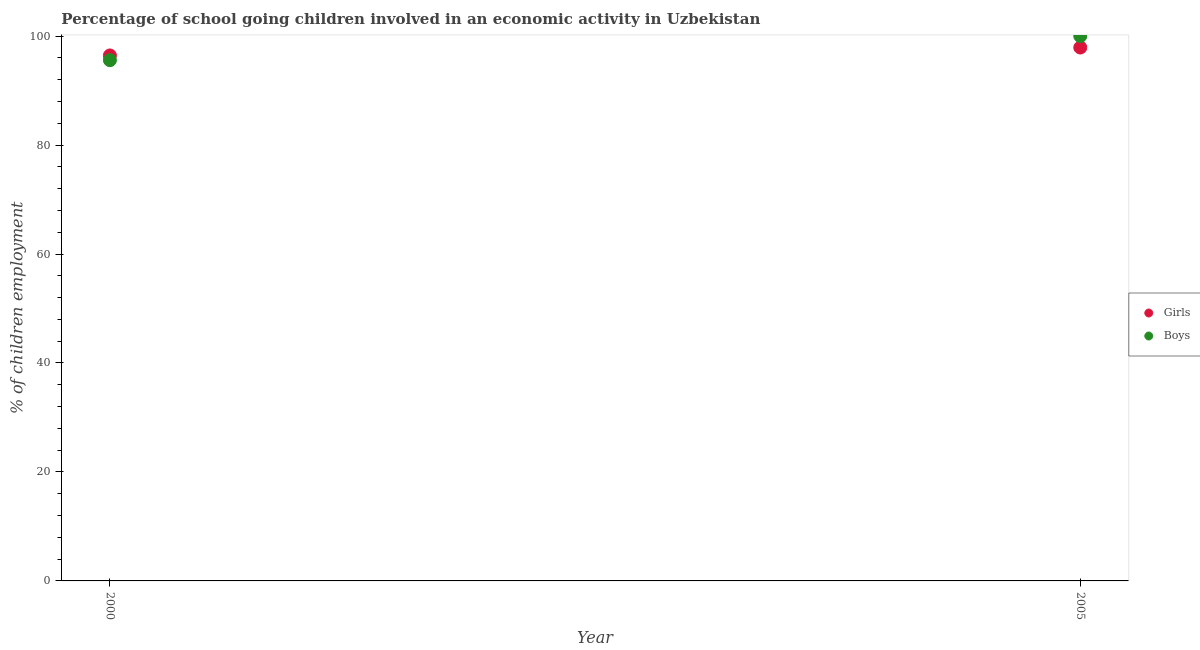Is the number of dotlines equal to the number of legend labels?
Provide a short and direct response. Yes. What is the percentage of school going boys in 2005?
Provide a short and direct response. 100. Across all years, what is the maximum percentage of school going girls?
Your response must be concise. 97.9. Across all years, what is the minimum percentage of school going girls?
Ensure brevity in your answer.  96.45. What is the total percentage of school going girls in the graph?
Provide a short and direct response. 194.35. What is the difference between the percentage of school going girls in 2000 and that in 2005?
Give a very brief answer. -1.45. What is the difference between the percentage of school going girls in 2000 and the percentage of school going boys in 2005?
Offer a very short reply. -3.55. What is the average percentage of school going boys per year?
Keep it short and to the point. 97.79. In the year 2000, what is the difference between the percentage of school going boys and percentage of school going girls?
Keep it short and to the point. -0.87. What is the ratio of the percentage of school going girls in 2000 to that in 2005?
Offer a terse response. 0.99. Is the percentage of school going boys in 2000 less than that in 2005?
Keep it short and to the point. Yes. Does the percentage of school going girls monotonically increase over the years?
Your answer should be compact. Yes. Is the percentage of school going boys strictly greater than the percentage of school going girls over the years?
Your answer should be compact. No. How many dotlines are there?
Ensure brevity in your answer.  2. How many years are there in the graph?
Make the answer very short. 2. Where does the legend appear in the graph?
Provide a succinct answer. Center right. What is the title of the graph?
Provide a succinct answer. Percentage of school going children involved in an economic activity in Uzbekistan. What is the label or title of the Y-axis?
Give a very brief answer. % of children employment. What is the % of children employment in Girls in 2000?
Provide a short and direct response. 96.45. What is the % of children employment in Boys in 2000?
Your response must be concise. 95.58. What is the % of children employment of Girls in 2005?
Your answer should be compact. 97.9. What is the % of children employment of Boys in 2005?
Give a very brief answer. 100. Across all years, what is the maximum % of children employment in Girls?
Keep it short and to the point. 97.9. Across all years, what is the maximum % of children employment of Boys?
Ensure brevity in your answer.  100. Across all years, what is the minimum % of children employment in Girls?
Keep it short and to the point. 96.45. Across all years, what is the minimum % of children employment in Boys?
Provide a succinct answer. 95.58. What is the total % of children employment in Girls in the graph?
Keep it short and to the point. 194.35. What is the total % of children employment in Boys in the graph?
Keep it short and to the point. 195.58. What is the difference between the % of children employment of Girls in 2000 and that in 2005?
Ensure brevity in your answer.  -1.45. What is the difference between the % of children employment in Boys in 2000 and that in 2005?
Provide a succinct answer. -4.42. What is the difference between the % of children employment of Girls in 2000 and the % of children employment of Boys in 2005?
Your answer should be compact. -3.55. What is the average % of children employment in Girls per year?
Keep it short and to the point. 97.17. What is the average % of children employment in Boys per year?
Provide a short and direct response. 97.79. In the year 2000, what is the difference between the % of children employment of Girls and % of children employment of Boys?
Offer a terse response. 0.87. What is the ratio of the % of children employment of Girls in 2000 to that in 2005?
Give a very brief answer. 0.99. What is the ratio of the % of children employment in Boys in 2000 to that in 2005?
Provide a succinct answer. 0.96. What is the difference between the highest and the second highest % of children employment in Girls?
Offer a very short reply. 1.45. What is the difference between the highest and the second highest % of children employment of Boys?
Your answer should be very brief. 4.42. What is the difference between the highest and the lowest % of children employment of Girls?
Your response must be concise. 1.45. What is the difference between the highest and the lowest % of children employment in Boys?
Keep it short and to the point. 4.42. 